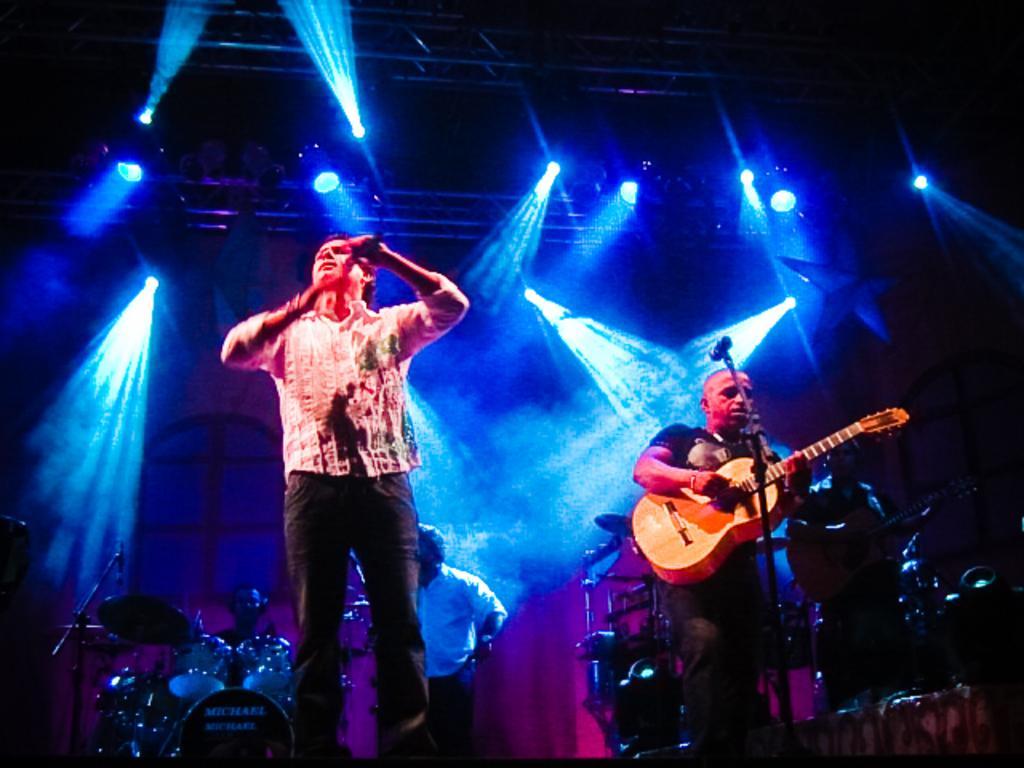Can you describe this image briefly? In this image i can see a man standing and holding a microphone in his hand, and to the right of the image i can see another person standing and holding a guitar in his hand. In the background i can see another person standing, drums and lights. 